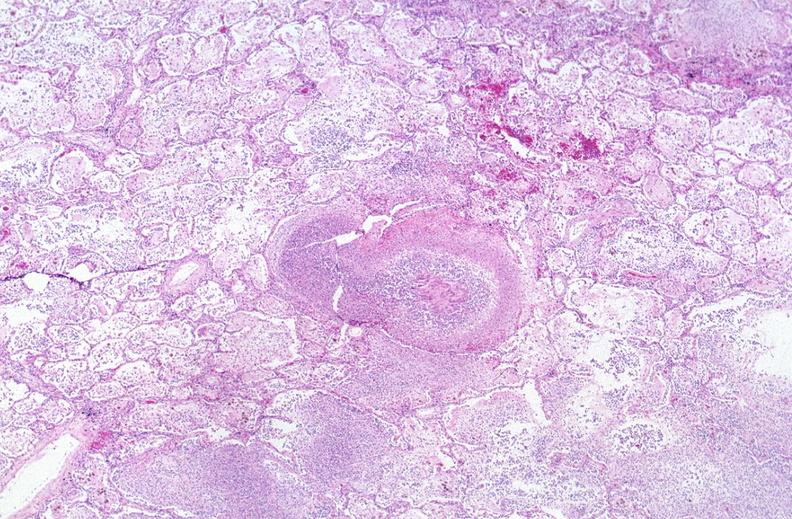what is present?
Answer the question using a single word or phrase. Respiratory 